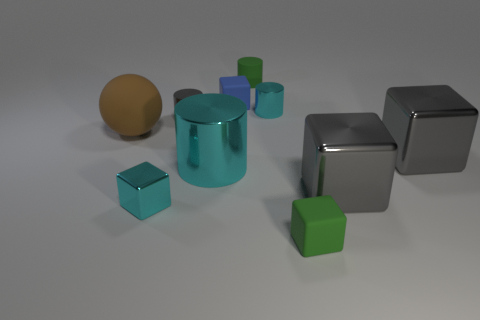Subtract all blue cubes. How many cyan cylinders are left? 2 Subtract all tiny matte cylinders. How many cylinders are left? 3 Subtract all blue cubes. How many cubes are left? 4 Subtract all balls. How many objects are left? 9 Subtract all red blocks. Subtract all green spheres. How many blocks are left? 5 Subtract all brown rubber spheres. Subtract all green objects. How many objects are left? 7 Add 8 gray blocks. How many gray blocks are left? 10 Add 4 tiny metal cylinders. How many tiny metal cylinders exist? 6 Subtract 0 blue spheres. How many objects are left? 10 